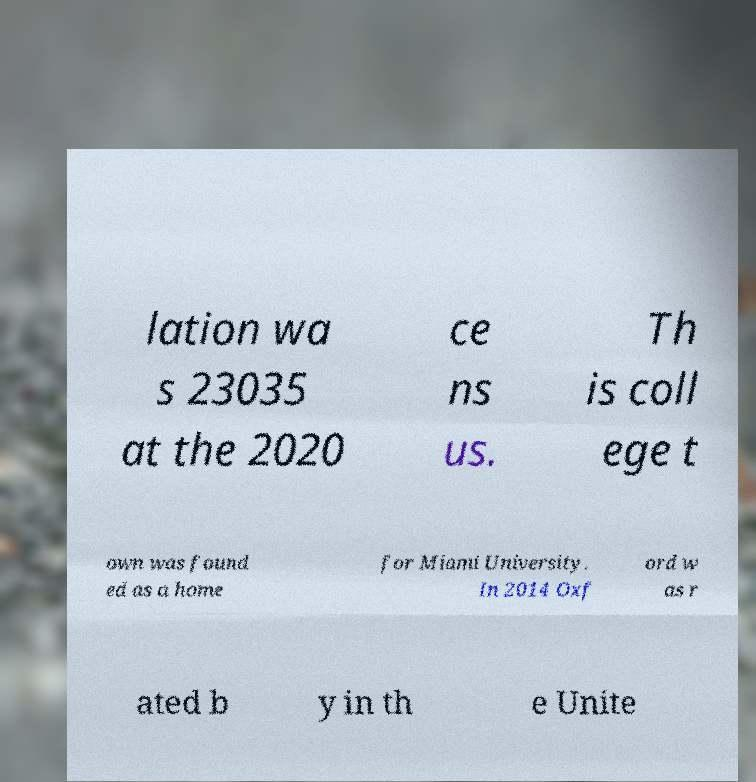Can you accurately transcribe the text from the provided image for me? lation wa s 23035 at the 2020 ce ns us. Th is coll ege t own was found ed as a home for Miami University. In 2014 Oxf ord w as r ated b y in th e Unite 